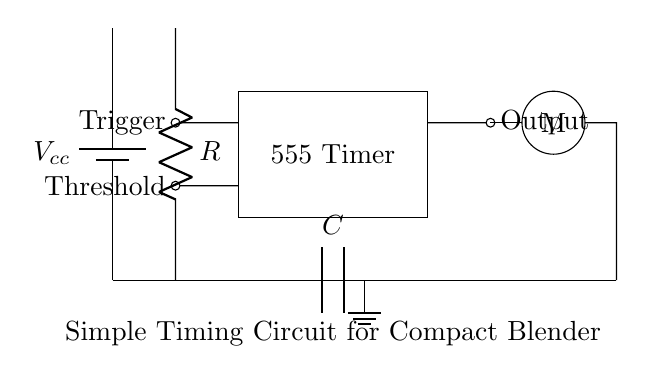What is the main component of this circuit? The main component is the 555 Timer, which is indicated in the circuit as a rectangular box with the label. It is responsible for timing functions in the circuit.
Answer: 555 Timer What does the capacitor represent in this circuit? The capacitor in this circuit is labeled as C, which is used in conjunction with the resistor R to determine the timing interval for the motor’s operation. The behavior of the timing circuit relies on the charge and discharge rates of this capacitor.
Answer: Timing interval How many terminals does the 555 Timer have in this circuit? The 555 Timer has three key terminals connected: Trigger, Threshold, and Output. These terminals play essential roles in its operation as a timer, controlling when the motor operates.
Answer: Three What is the function of the resistor in this circuit? The resistor, labeled R, is part of the timing configuration with the capacitor. It influences the charging time of the capacitor, which in turn affects the timing duration for the blender's motor operation.
Answer: Timing configuration What type of device is represented by the circular symbol with "M"? The circular symbol labeled M represents the motor of the blender or food processor. Its position in the circuit shows that it's the load being powered by the results of the timing circuit.
Answer: Motor Which component is responsible for triggering the 555 Timer? The component responsible for triggering the 555 Timer is the Trigger terminal, which is specifically connected to the input that initiates the timing sequence when a low voltage pulse is applied.
Answer: Trigger terminal 